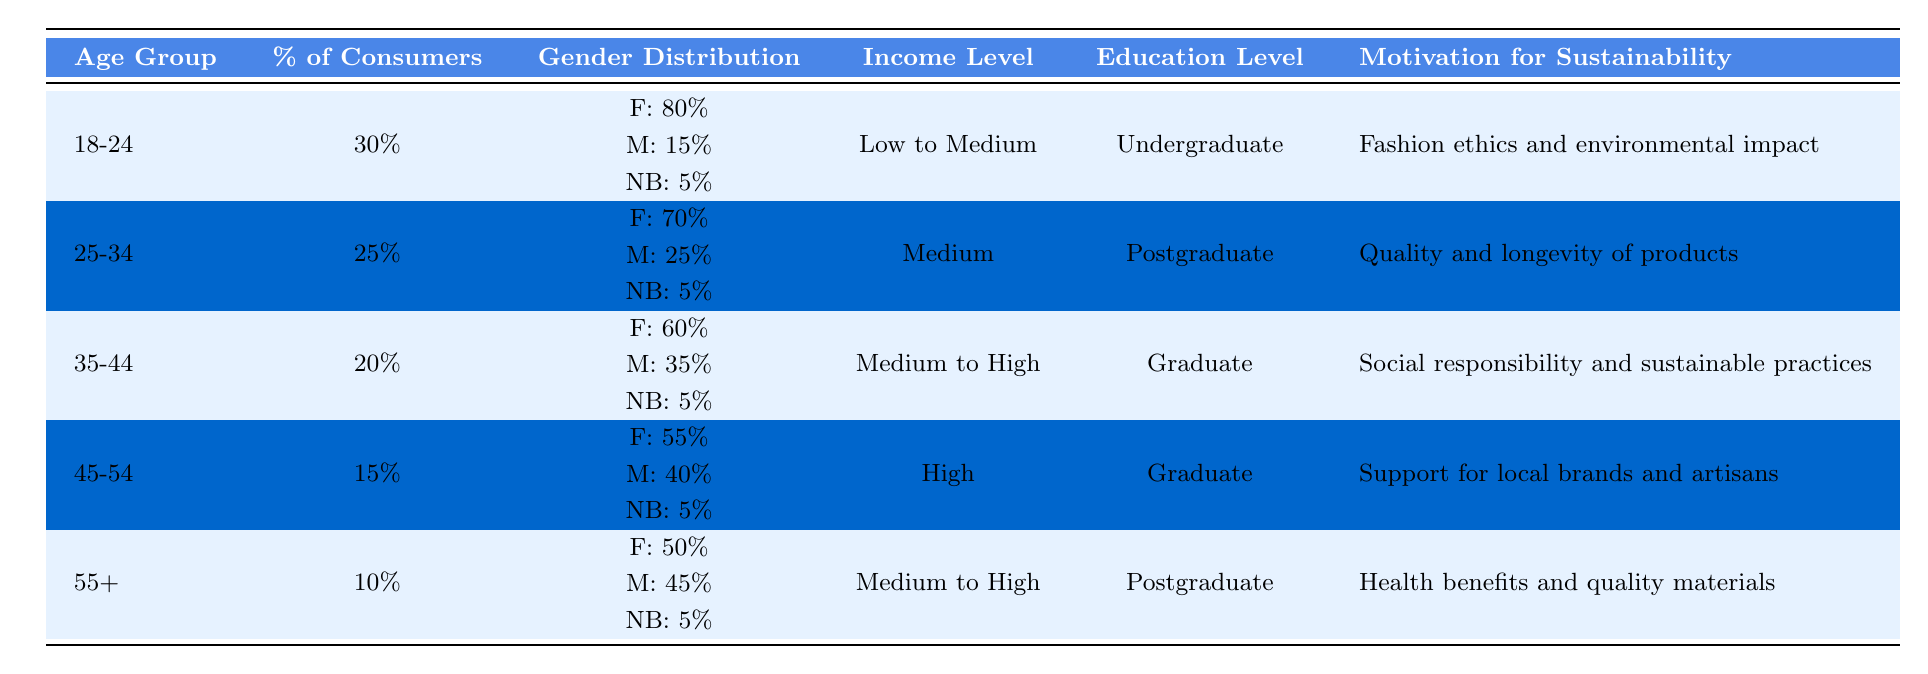What percentage of sustainable fashion consumers are in the 18-24 age group? According to the table, the percentage of sustainable fashion consumers in the 18-24 age group is explicitly listed as 30%.
Answer: 30% Which age group has the highest percentage of sustainable fashion consumers? The age group with the highest percentage of sustainable fashion consumers is 18-24, who make up 30% of the total consumers.
Answer: 18-24 What is the gender distribution of the 25-34 age group? In the 25-34 age group, the gender distribution is 70% female, 25% male, and 5% non-binary. This information is directly provided in the table.
Answer: F: 70%, M: 25%, NB: 5% Is the majority of the 35-44 age group composed of males? No, the majority of the 35-44 age group is not composed of males; it is 60% female, which is more than the 35% male proportion.
Answer: No What is the average percentage of consumers across all age groups? To find the average percentage, we sum the percentages: 30% + 25% + 20% + 15% + 10% = 100%. There are 5 age groups, so the average is 100% / 5 = 20%.
Answer: 20% What motivates the majority of consumers aged 45-54 toward sustainability? The majority of consumers aged 45-54 are motivated by supporting local brands and artisans. This motivation is specifically mentioned for this age group in the table.
Answer: Support for local brands and artisans Are there more females or males in the 55+ age group based on the data? In the 55+ age group, there are more males, with 45% compared to 50% females. However, this still indicates a higher percentage of females.
Answer: Yes, more females Which group has the lowest percentage of sustainable fashion consumers and what is the motivation for that group? The group with the lowest percentage of sustainable fashion consumers is the 55+ age group, with 10%. Their motivation for sustainability is health benefits and quality materials, as stated in the table.
Answer: 55+, health benefits and quality materials 